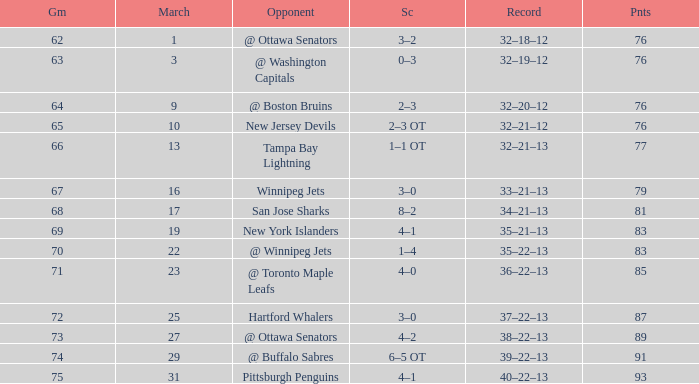How many games have a March of 19, and Points smaller than 83? 0.0. 